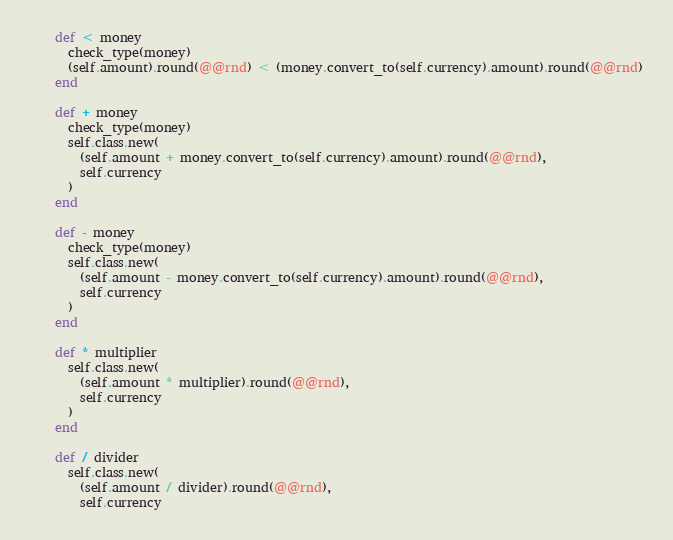<code> <loc_0><loc_0><loc_500><loc_500><_Ruby_>    def < money
      check_type(money)
      (self.amount).round(@@rnd) < (money.convert_to(self.currency).amount).round(@@rnd)
    end

    def + money
      check_type(money)
      self.class.new(
        (self.amount + money.convert_to(self.currency).amount).round(@@rnd),
        self.currency
      )
    end

    def - money
      check_type(money)
      self.class.new(
        (self.amount - money.convert_to(self.currency).amount).round(@@rnd),
        self.currency
      )
    end

    def * multiplier
      self.class.new(
        (self.amount * multiplier).round(@@rnd),
        self.currency
      )
    end

    def / divider
      self.class.new(
        (self.amount / divider).round(@@rnd),
        self.currency</code> 